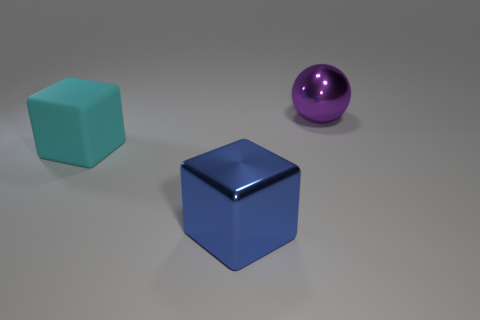Subtract all cubes. How many objects are left? 1 Subtract 1 cubes. How many cubes are left? 1 Subtract all blue balls. Subtract all blue cylinders. How many balls are left? 1 Subtract all cyan cubes. How many gray spheres are left? 0 Subtract all blue rubber cubes. Subtract all purple metal spheres. How many objects are left? 2 Add 1 purple metal things. How many purple metal things are left? 2 Add 2 big rubber blocks. How many big rubber blocks exist? 3 Add 3 large yellow rubber balls. How many objects exist? 6 Subtract all cyan blocks. How many blocks are left? 1 Subtract 0 blue cylinders. How many objects are left? 3 